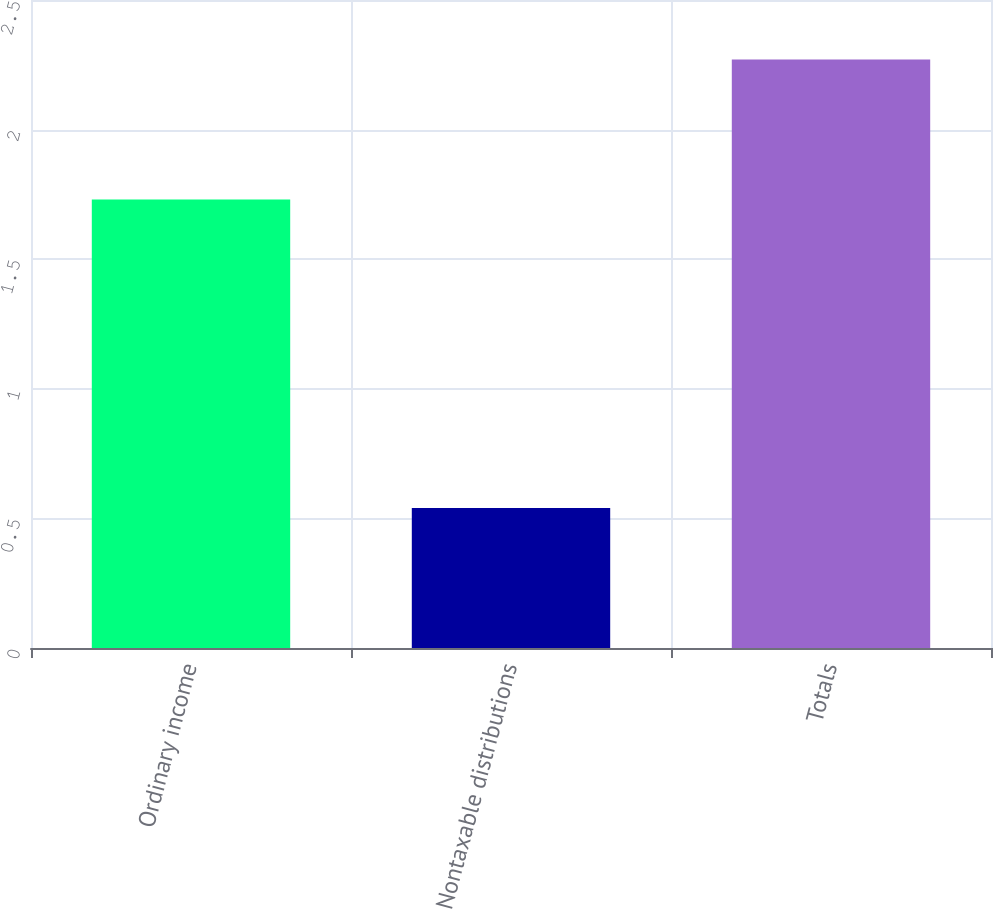Convert chart. <chart><loc_0><loc_0><loc_500><loc_500><bar_chart><fcel>Ordinary income<fcel>Nontaxable distributions<fcel>Totals<nl><fcel>1.73<fcel>0.54<fcel>2.27<nl></chart> 